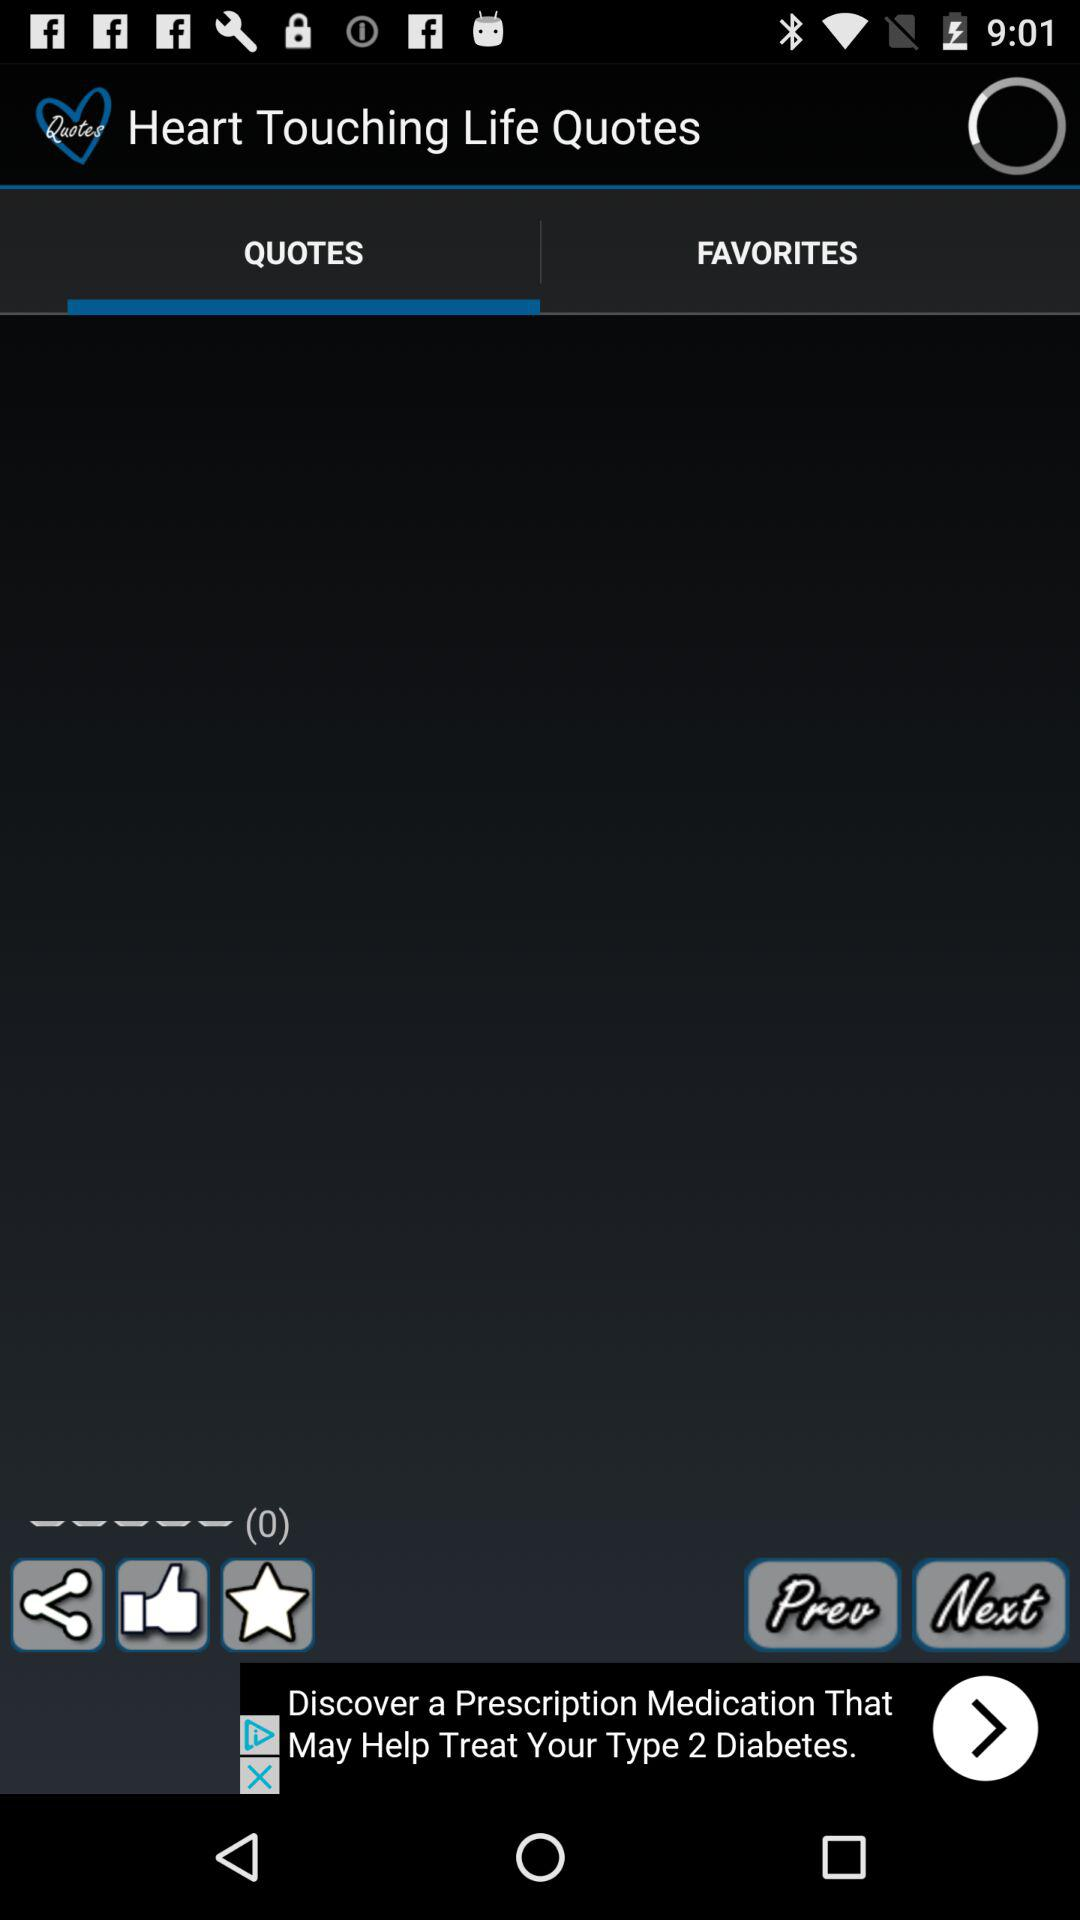What is the name of the application? The name of the application is "Heart Touching Life Quotes". 